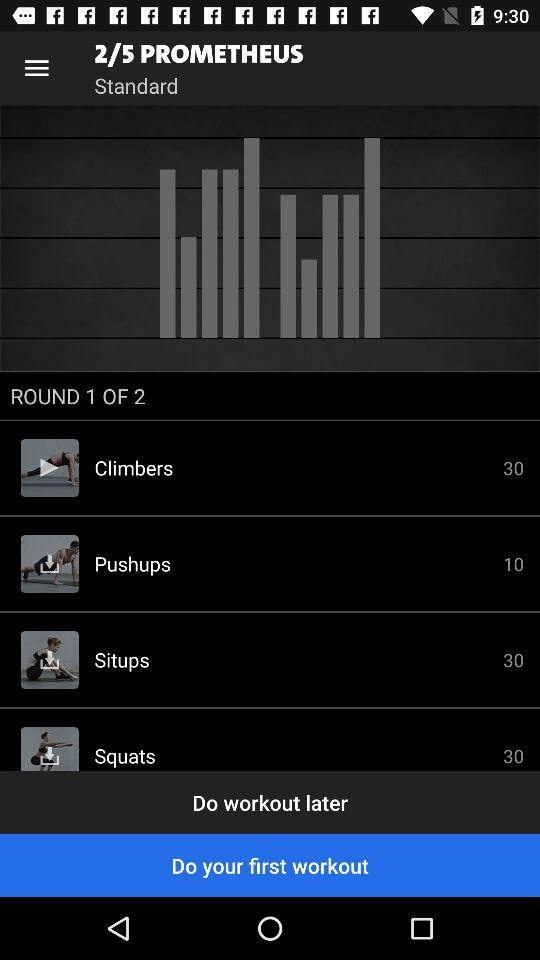What is the number of pages? The number of pages is 5. 